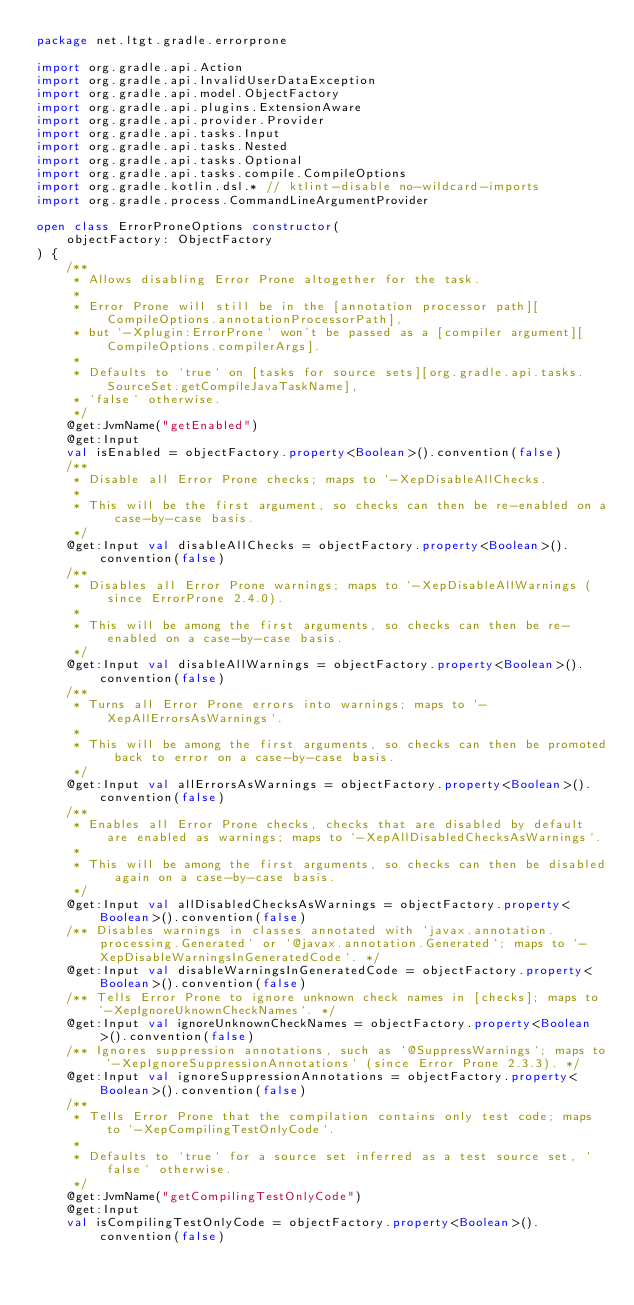<code> <loc_0><loc_0><loc_500><loc_500><_Kotlin_>package net.ltgt.gradle.errorprone

import org.gradle.api.Action
import org.gradle.api.InvalidUserDataException
import org.gradle.api.model.ObjectFactory
import org.gradle.api.plugins.ExtensionAware
import org.gradle.api.provider.Provider
import org.gradle.api.tasks.Input
import org.gradle.api.tasks.Nested
import org.gradle.api.tasks.Optional
import org.gradle.api.tasks.compile.CompileOptions
import org.gradle.kotlin.dsl.* // ktlint-disable no-wildcard-imports
import org.gradle.process.CommandLineArgumentProvider

open class ErrorProneOptions constructor(
    objectFactory: ObjectFactory
) {
    /**
     * Allows disabling Error Prone altogether for the task.
     *
     * Error Prone will still be in the [annotation processor path][CompileOptions.annotationProcessorPath],
     * but `-Xplugin:ErrorProne` won't be passed as a [compiler argument][CompileOptions.compilerArgs].
     *
     * Defaults to `true` on [tasks for source sets][org.gradle.api.tasks.SourceSet.getCompileJavaTaskName],
     * `false` otherwise.
     */
    @get:JvmName("getEnabled")
    @get:Input
    val isEnabled = objectFactory.property<Boolean>().convention(false)
    /**
     * Disable all Error Prone checks; maps to `-XepDisableAllChecks.
     *
     * This will be the first argument, so checks can then be re-enabled on a case-by-case basis.
     */
    @get:Input val disableAllChecks = objectFactory.property<Boolean>().convention(false)
    /**
     * Disables all Error Prone warnings; maps to `-XepDisableAllWarnings (since ErrorProne 2.4.0).
     *
     * This will be among the first arguments, so checks can then be re-enabled on a case-by-case basis.
     */
    @get:Input val disableAllWarnings = objectFactory.property<Boolean>().convention(false)
    /**
     * Turns all Error Prone errors into warnings; maps to `-XepAllErrorsAsWarnings`.
     *
     * This will be among the first arguments, so checks can then be promoted back to error on a case-by-case basis.
     */
    @get:Input val allErrorsAsWarnings = objectFactory.property<Boolean>().convention(false)
    /**
     * Enables all Error Prone checks, checks that are disabled by default are enabled as warnings; maps to `-XepAllDisabledChecksAsWarnings`.
     *
     * This will be among the first arguments, so checks can then be disabled again on a case-by-case basis.
     */
    @get:Input val allDisabledChecksAsWarnings = objectFactory.property<Boolean>().convention(false)
    /** Disables warnings in classes annotated with `javax.annotation.processing.Generated` or `@javax.annotation.Generated`; maps to `-XepDisableWarningsInGeneratedCode`. */
    @get:Input val disableWarningsInGeneratedCode = objectFactory.property<Boolean>().convention(false)
    /** Tells Error Prone to ignore unknown check names in [checks]; maps to `-XepIgnoreUknownCheckNames`. */
    @get:Input val ignoreUnknownCheckNames = objectFactory.property<Boolean>().convention(false)
    /** Ignores suppression annotations, such as `@SuppressWarnings`; maps to `-XepIgnoreSuppressionAnnotations` (since Error Prone 2.3.3). */
    @get:Input val ignoreSuppressionAnnotations = objectFactory.property<Boolean>().convention(false)
    /**
     * Tells Error Prone that the compilation contains only test code; maps to `-XepCompilingTestOnlyCode`.
     *
     * Defaults to `true` for a source set inferred as a test source set, `false` otherwise.
     */
    @get:JvmName("getCompilingTestOnlyCode")
    @get:Input
    val isCompilingTestOnlyCode = objectFactory.property<Boolean>().convention(false)</code> 